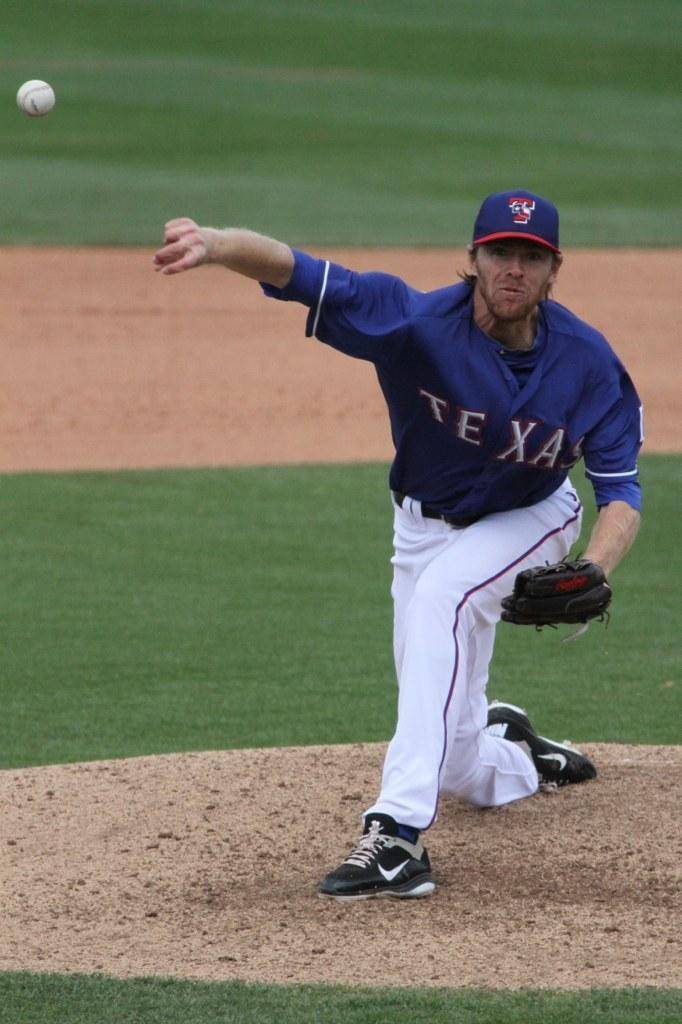Provide a one-sentence caption for the provided image. A Texas baseball pitcher in a blue jersey and white pants pitching a ball. 